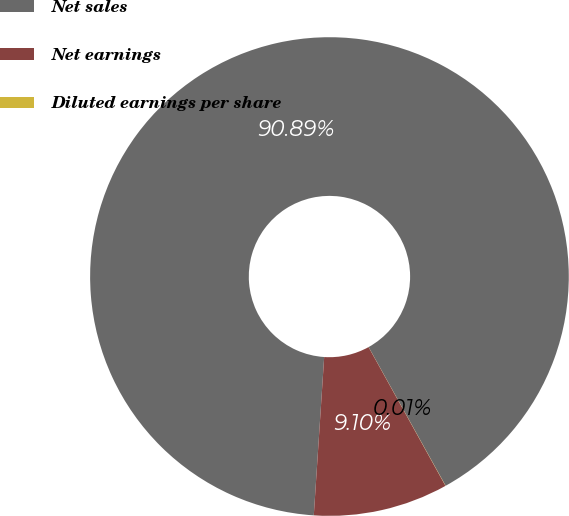<chart> <loc_0><loc_0><loc_500><loc_500><pie_chart><fcel>Net sales<fcel>Net earnings<fcel>Diluted earnings per share<nl><fcel>90.89%<fcel>9.1%<fcel>0.01%<nl></chart> 